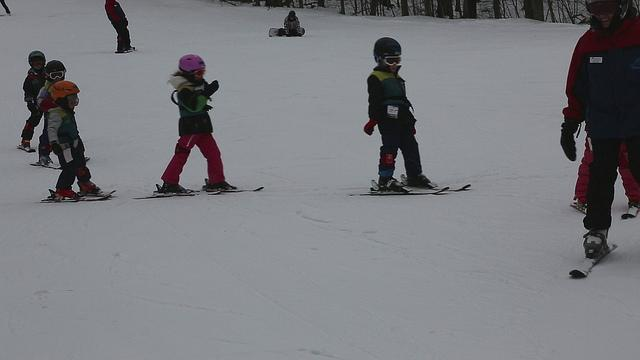What sort of lesson might the short people be getting?

Choices:
A) beginner ski
B) olympic ski
C) marshmallows
D) kittens beginner ski 